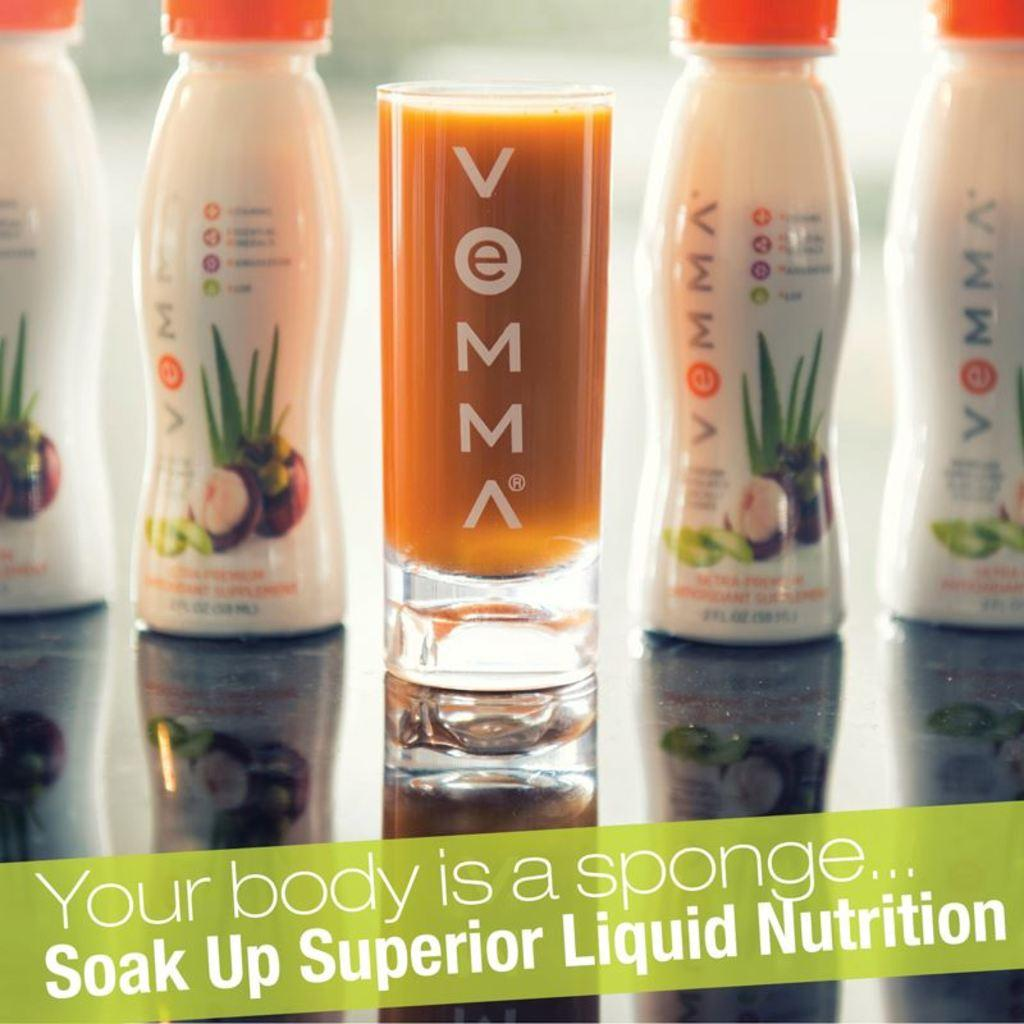<image>
Offer a succinct explanation of the picture presented. Soak up superior liquid nutrition; an ad for a smoothie. 